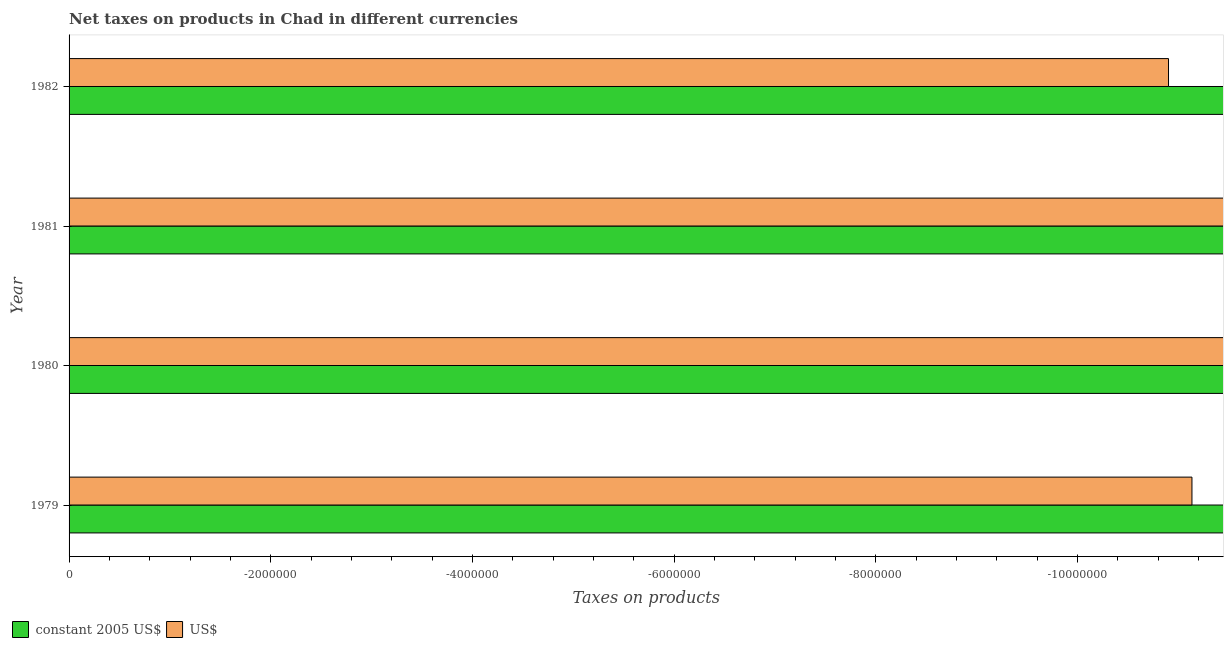How many different coloured bars are there?
Ensure brevity in your answer.  0. How many bars are there on the 1st tick from the bottom?
Offer a terse response. 0. Across all years, what is the minimum net taxes in constant 2005 us$?
Your answer should be compact. 0. What is the total net taxes in us$ in the graph?
Provide a succinct answer. 0. What is the difference between the net taxes in us$ in 1979 and the net taxes in constant 2005 us$ in 1980?
Your answer should be very brief. 0. In how many years, is the net taxes in us$ greater than -11200000 units?
Your answer should be very brief. 2. How many bars are there?
Make the answer very short. 0. How many years are there in the graph?
Offer a very short reply. 4. Are the values on the major ticks of X-axis written in scientific E-notation?
Give a very brief answer. No. Where does the legend appear in the graph?
Your answer should be compact. Bottom left. How many legend labels are there?
Offer a very short reply. 2. What is the title of the graph?
Your answer should be compact. Net taxes on products in Chad in different currencies. Does "Diarrhea" appear as one of the legend labels in the graph?
Offer a terse response. No. What is the label or title of the X-axis?
Your answer should be very brief. Taxes on products. What is the Taxes on products in constant 2005 US$ in 1979?
Keep it short and to the point. 0. What is the Taxes on products in US$ in 1979?
Offer a terse response. 0. What is the Taxes on products in constant 2005 US$ in 1980?
Keep it short and to the point. 0. What is the Taxes on products in US$ in 1980?
Provide a short and direct response. 0. What is the Taxes on products in constant 2005 US$ in 1981?
Your answer should be very brief. 0. What is the Taxes on products of US$ in 1981?
Provide a short and direct response. 0. What is the Taxes on products of constant 2005 US$ in 1982?
Keep it short and to the point. 0. What is the Taxes on products of US$ in 1982?
Your answer should be compact. 0. What is the total Taxes on products in constant 2005 US$ in the graph?
Offer a very short reply. 0. What is the total Taxes on products in US$ in the graph?
Offer a very short reply. 0. What is the average Taxes on products in constant 2005 US$ per year?
Give a very brief answer. 0. What is the average Taxes on products of US$ per year?
Ensure brevity in your answer.  0. 